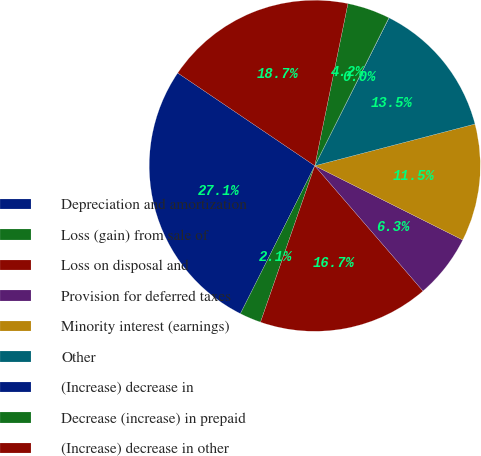Convert chart. <chart><loc_0><loc_0><loc_500><loc_500><pie_chart><fcel>Depreciation and amortization<fcel>Loss (gain) from sale of<fcel>Loss on disposal and<fcel>Provision for deferred taxes<fcel>Minority interest (earnings)<fcel>Other<fcel>(Increase) decrease in<fcel>Decrease (increase) in prepaid<fcel>(Increase) decrease in other<nl><fcel>27.06%<fcel>2.1%<fcel>16.66%<fcel>6.26%<fcel>11.46%<fcel>13.54%<fcel>0.02%<fcel>4.18%<fcel>18.74%<nl></chart> 